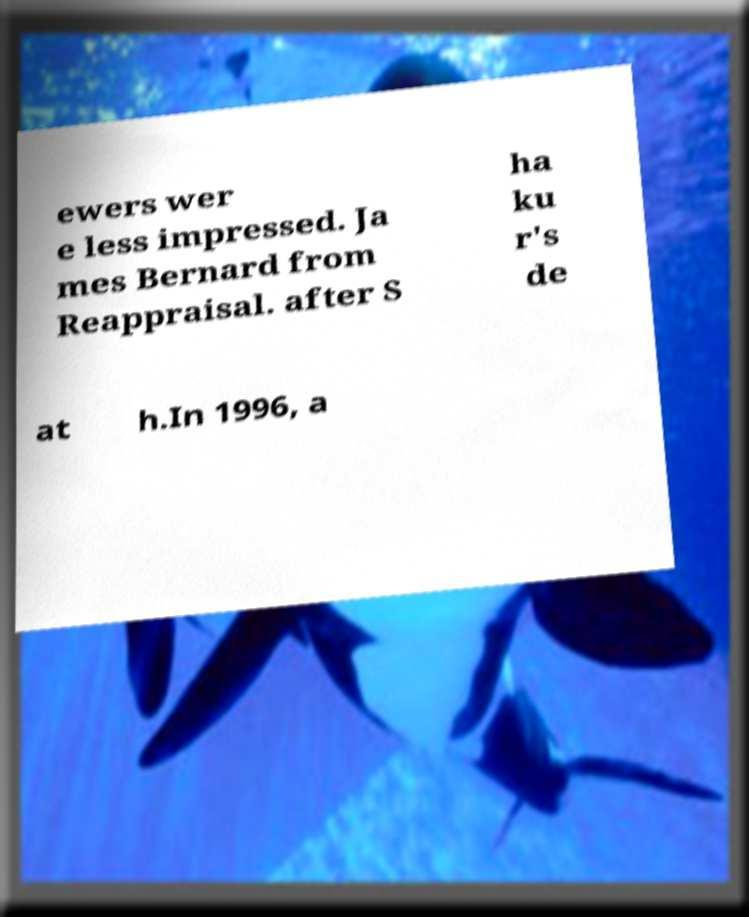I need the written content from this picture converted into text. Can you do that? ewers wer e less impressed. Ja mes Bernard from Reappraisal. after S ha ku r's de at h.In 1996, a 